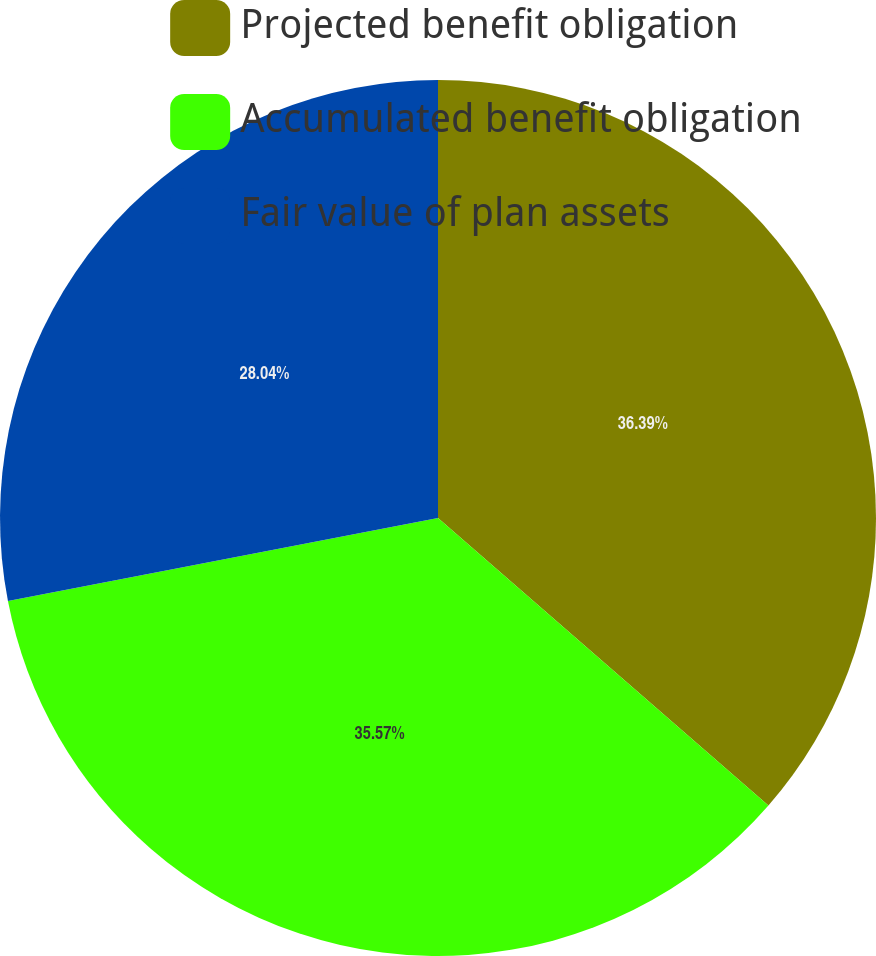<chart> <loc_0><loc_0><loc_500><loc_500><pie_chart><fcel>Projected benefit obligation<fcel>Accumulated benefit obligation<fcel>Fair value of plan assets<nl><fcel>36.4%<fcel>35.57%<fcel>28.04%<nl></chart> 